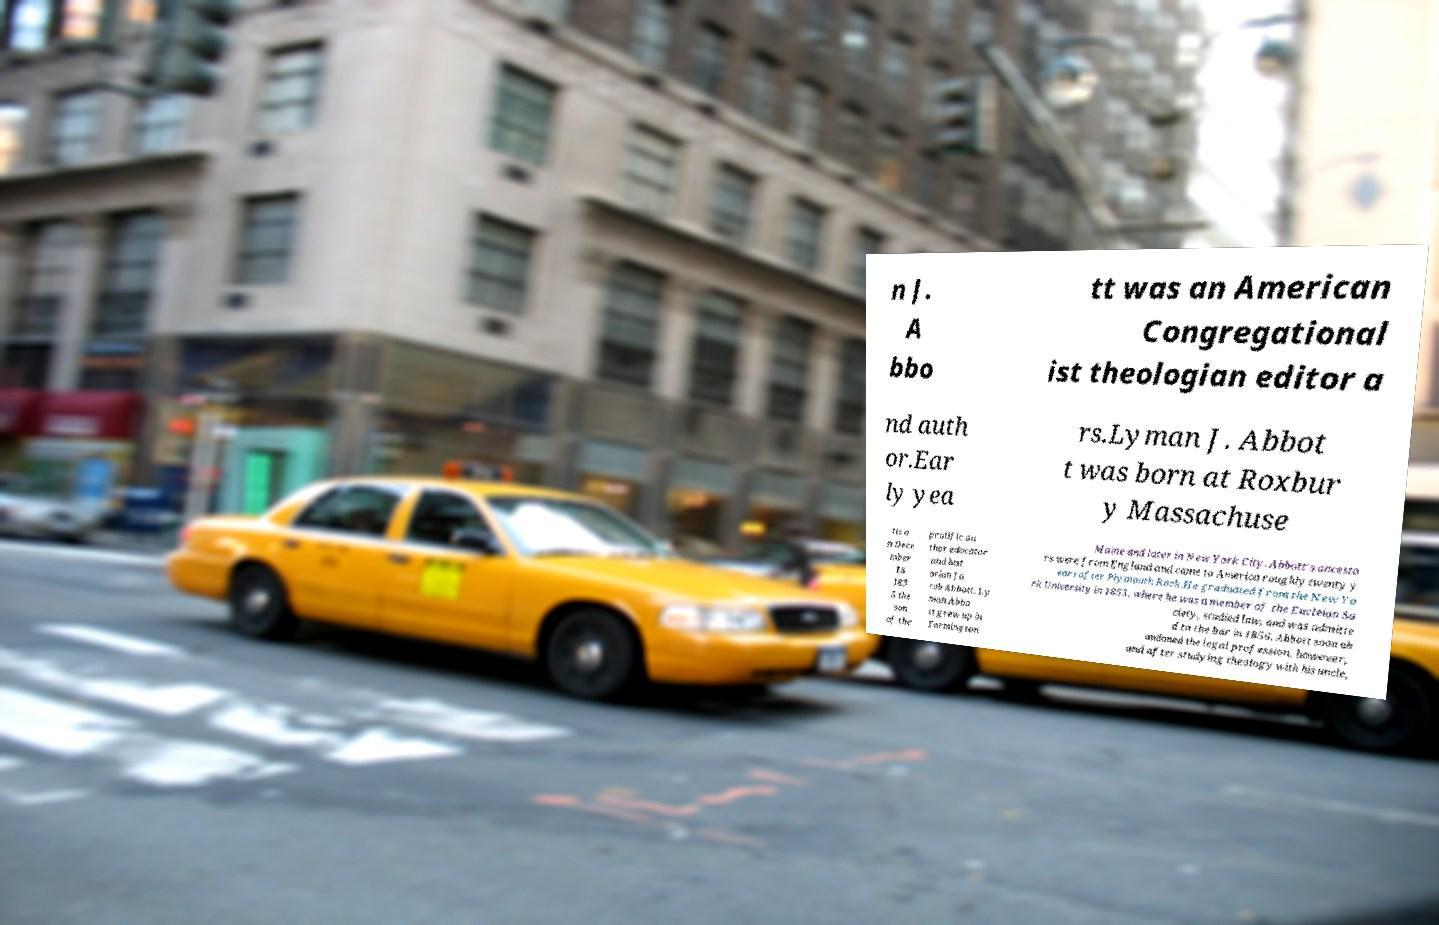Can you read and provide the text displayed in the image?This photo seems to have some interesting text. Can you extract and type it out for me? n J. A bbo tt was an American Congregational ist theologian editor a nd auth or.Ear ly yea rs.Lyman J. Abbot t was born at Roxbur y Massachuse tts o n Dece mber 18 183 5 the son of the prolific au thor educator and hist orian Ja cob Abbott. Ly man Abbo tt grew up in Farmington Maine and later in New York City. Abbott's ancesto rs were from England and came to America roughly twenty y ears after Plymouth Rock.He graduated from the New Yo rk University in 1853, where he was a member of the Eucleian So ciety, studied law, and was admitte d to the bar in 1856. Abbott soon ab andoned the legal profession, however, and after studying theology with his uncle, 